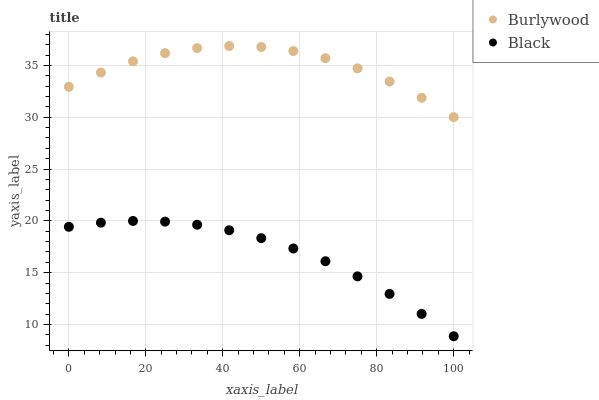Does Black have the minimum area under the curve?
Answer yes or no. Yes. Does Burlywood have the maximum area under the curve?
Answer yes or no. Yes. Does Black have the maximum area under the curve?
Answer yes or no. No. Is Black the smoothest?
Answer yes or no. Yes. Is Burlywood the roughest?
Answer yes or no. Yes. Is Black the roughest?
Answer yes or no. No. Does Black have the lowest value?
Answer yes or no. Yes. Does Burlywood have the highest value?
Answer yes or no. Yes. Does Black have the highest value?
Answer yes or no. No. Is Black less than Burlywood?
Answer yes or no. Yes. Is Burlywood greater than Black?
Answer yes or no. Yes. Does Black intersect Burlywood?
Answer yes or no. No. 